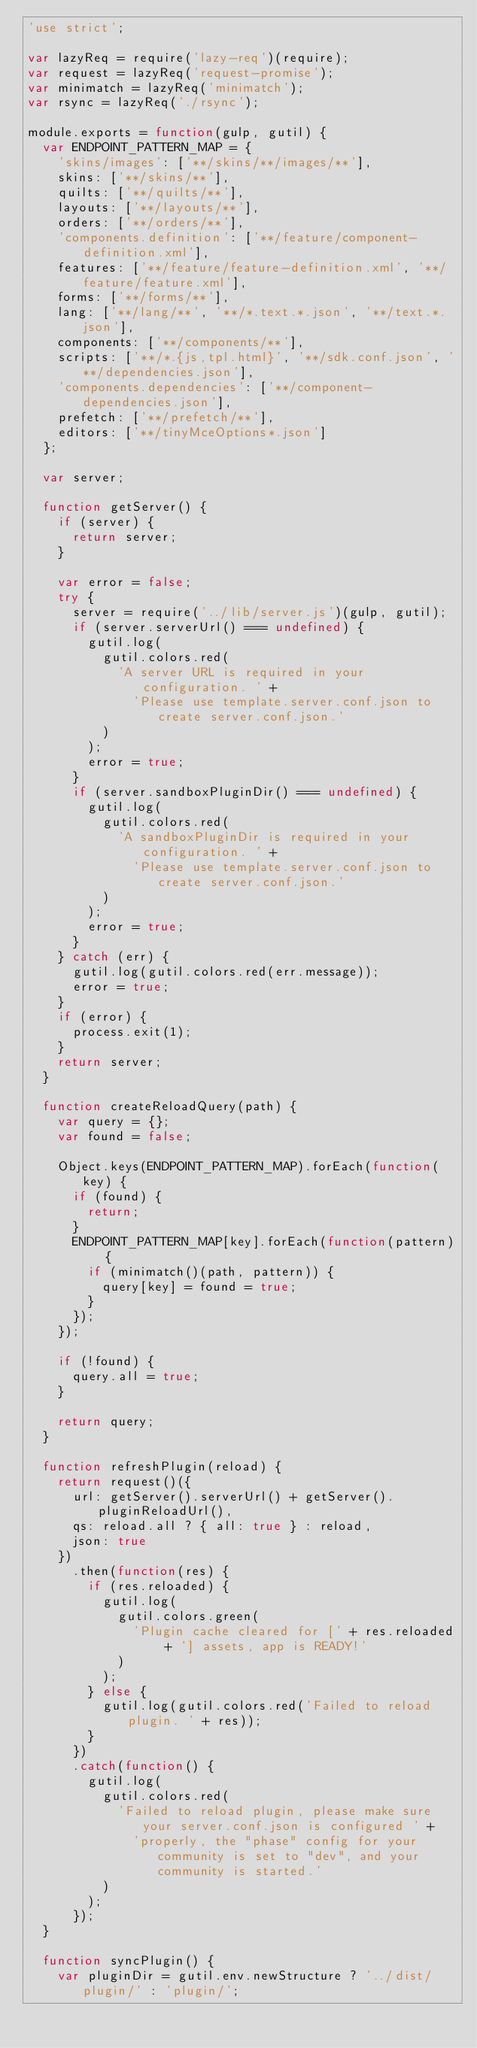<code> <loc_0><loc_0><loc_500><loc_500><_JavaScript_>'use strict';

var lazyReq = require('lazy-req')(require);
var request = lazyReq('request-promise');
var minimatch = lazyReq('minimatch');
var rsync = lazyReq('./rsync');

module.exports = function(gulp, gutil) {
  var ENDPOINT_PATTERN_MAP = {
    'skins/images': ['**/skins/**/images/**'],
    skins: ['**/skins/**'],
    quilts: ['**/quilts/**'],
    layouts: ['**/layouts/**'],
    orders: ['**/orders/**'],
    'components.definition': ['**/feature/component-definition.xml'],
    features: ['**/feature/feature-definition.xml', '**/feature/feature.xml'],
    forms: ['**/forms/**'],
    lang: ['**/lang/**', '**/*.text.*.json', '**/text.*.json'],
    components: ['**/components/**'],
    scripts: ['**/*.{js,tpl.html}', '**/sdk.conf.json', '**/dependencies.json'],
    'components.dependencies': ['**/component-dependencies.json'],
    prefetch: ['**/prefetch/**'],
    editors: ['**/tinyMceOptions*.json']
  };

  var server;

  function getServer() {
    if (server) {
      return server;
    }

    var error = false;
    try {
      server = require('../lib/server.js')(gulp, gutil);
      if (server.serverUrl() === undefined) {
        gutil.log(
          gutil.colors.red(
            'A server URL is required in your configuration. ' +
              'Please use template.server.conf.json to create server.conf.json.'
          )
        );
        error = true;
      }
      if (server.sandboxPluginDir() === undefined) {
        gutil.log(
          gutil.colors.red(
            'A sandboxPluginDir is required in your configuration. ' +
              'Please use template.server.conf.json to create server.conf.json.'
          )
        );
        error = true;
      }
    } catch (err) {
      gutil.log(gutil.colors.red(err.message));
      error = true;
    }
    if (error) {
      process.exit(1);
    }
    return server;
  }

  function createReloadQuery(path) {
    var query = {};
    var found = false;

    Object.keys(ENDPOINT_PATTERN_MAP).forEach(function(key) {
      if (found) {
        return;
      }
      ENDPOINT_PATTERN_MAP[key].forEach(function(pattern) {
        if (minimatch()(path, pattern)) {
          query[key] = found = true;
        }
      });
    });

    if (!found) {
      query.all = true;
    }

    return query;
  }

  function refreshPlugin(reload) {
    return request()({
      url: getServer().serverUrl() + getServer().pluginReloadUrl(),
      qs: reload.all ? { all: true } : reload,
      json: true
    })
      .then(function(res) {
        if (res.reloaded) {
          gutil.log(
            gutil.colors.green(
              'Plugin cache cleared for [' + res.reloaded + '] assets, app is READY!'
            )
          );
        } else {
          gutil.log(gutil.colors.red('Failed to reload plugin. ' + res));
        }
      })
      .catch(function() {
        gutil.log(
          gutil.colors.red(
            'Failed to reload plugin, please make sure your server.conf.json is configured ' +
              'properly, the "phase" config for your community is set to "dev", and your community is started.'
          )
        );
      });
  }

  function syncPlugin() {
    var pluginDir = gutil.env.newStructure ? '../dist/plugin/' : 'plugin/';</code> 